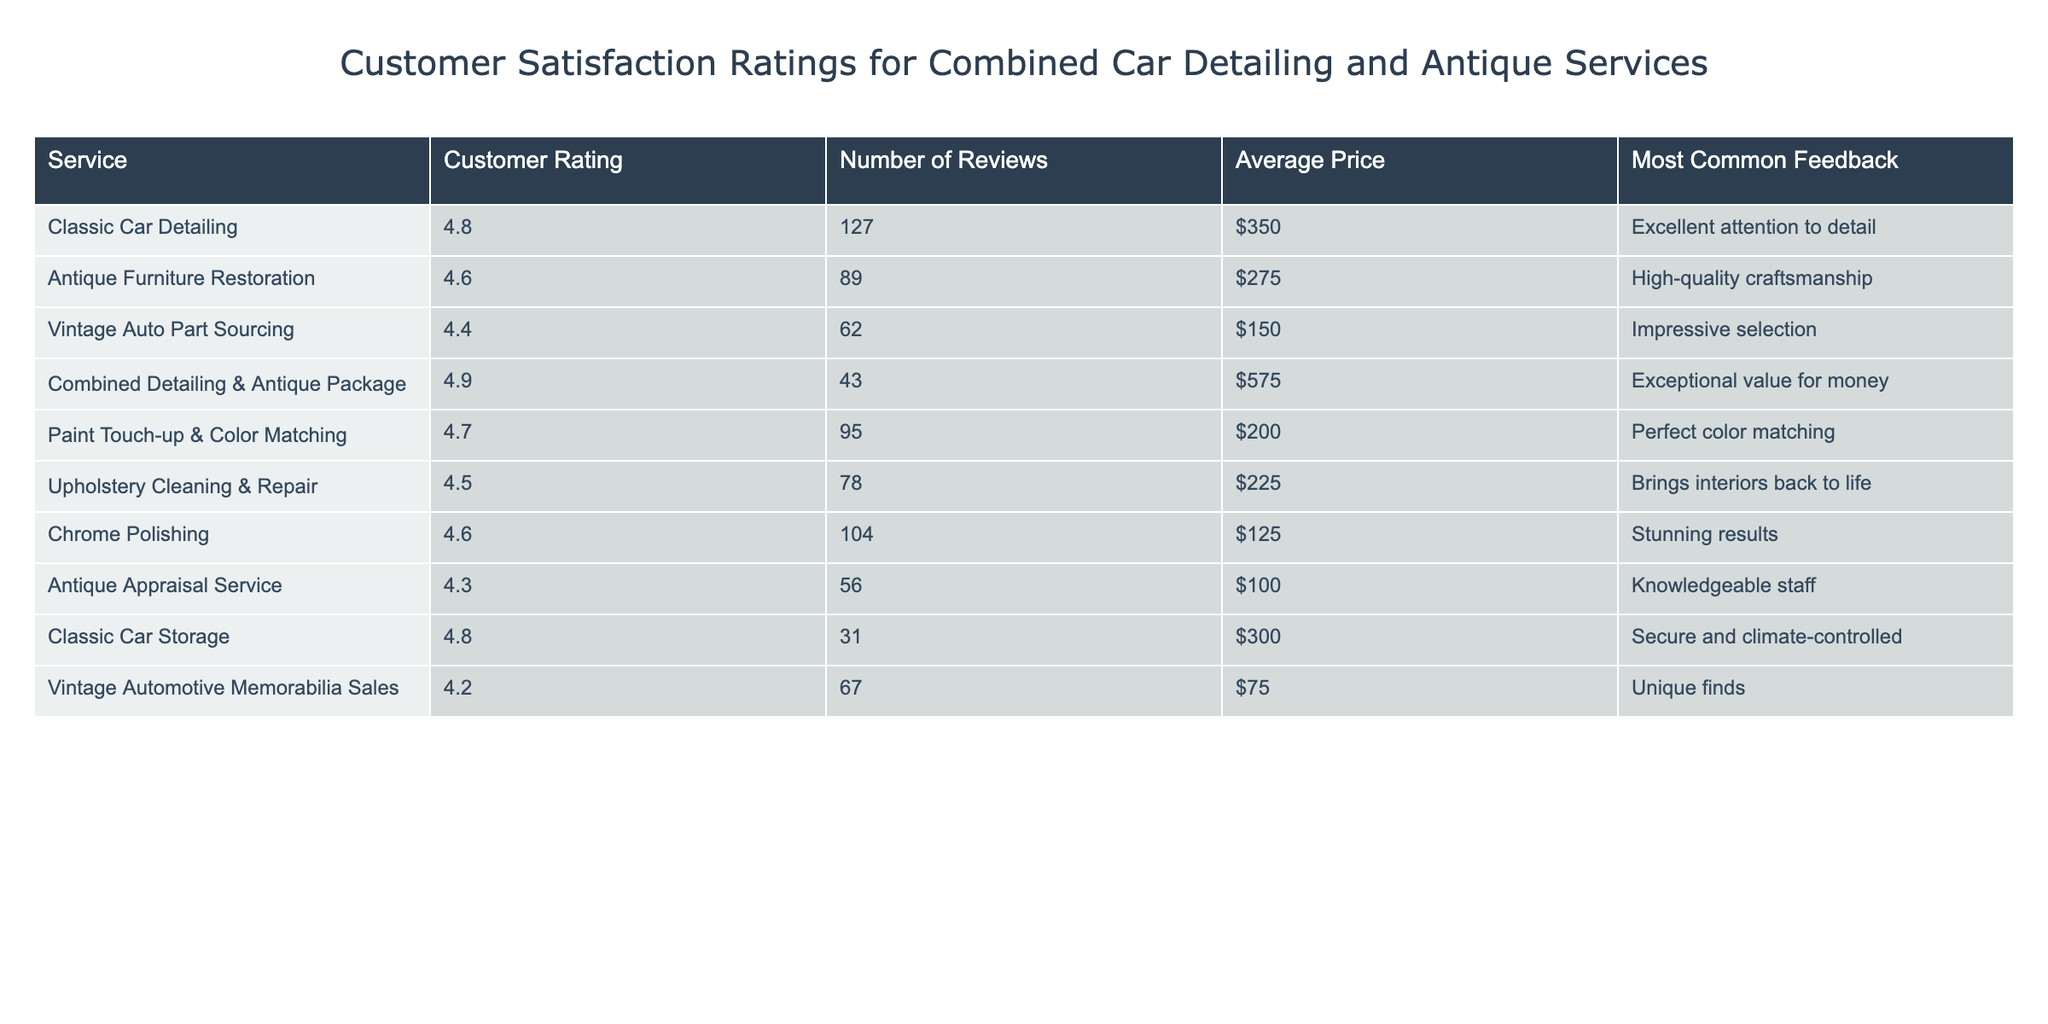What is the customer rating for the Combined Detailing & Antique Package? The table lists the rating for the Combined Detailing & Antique Package under the "Customer Rating" column, which is 4.9.
Answer: 4.9 How many reviews does the Antique Furniture Restoration service have? The table shows the number of reviews for Antique Furniture Restoration, which is 89.
Answer: 89 Which service has the highest customer rating? The customer ratings in the table indicate that the Combined Detailing & Antique Package has the highest rating of 4.9, compared to all other services listed.
Answer: Combined Detailing & Antique Package What is the average price of the Vintage Auto Part Sourcing service? The table specifies that the price of the Vintage Auto Part Sourcing service is $150, which is the answer.
Answer: $150 Which service received the most common feedback of "Excellent attention to detail"? The feedback listed for Classic Car Detailing mentions "Excellent attention to detail." This is found in the "Most Common Feedback" column.
Answer: Classic Car Detailing What is the difference in customer ratings between Antique Appraisal Service and Chrome Polishing? The customer rating for Antique Appraisal Service is 4.3 and for Chrome Polishing is 4.6. The difference is calculated as 4.6 - 4.3 = 0.3.
Answer: 0.3 What percentage of total reviews does the Combined Detailing & Antique Package account for? Summing the total reviews: 127 + 89 + 62 + 43 + 95 + 78 + 104 + 56 + 31 + 67 = 682. The Combined Detailing & Antique Package has 43 reviews, so the percentage is (43/682) * 100 = 6.31%.
Answer: 6.31% Which service offers the lowest average price? Comparing the average prices listed in the table, Vintage Automotive Memorabilia Sales has the lowest price at $75.
Answer: $75 Is the customer rating for Upholstery Cleaning & Repair above the average rating of the other services? The average rating of the other services (excluding Upholstery Cleaning & Repair) is calculated and then compared to 4.5 (the rating for Upholstery Cleaning & Repair). Since most services average about 4.5, Upholstery Cleaning & Repair is not above the average.
Answer: No What is the total number of reviews for all services combined? The total number of reviews is the sum of the values in the "Number of Reviews" column: 127 + 89 + 62 + 43 + 95 + 78 + 104 + 56 + 31 + 67 = 682.
Answer: 682 